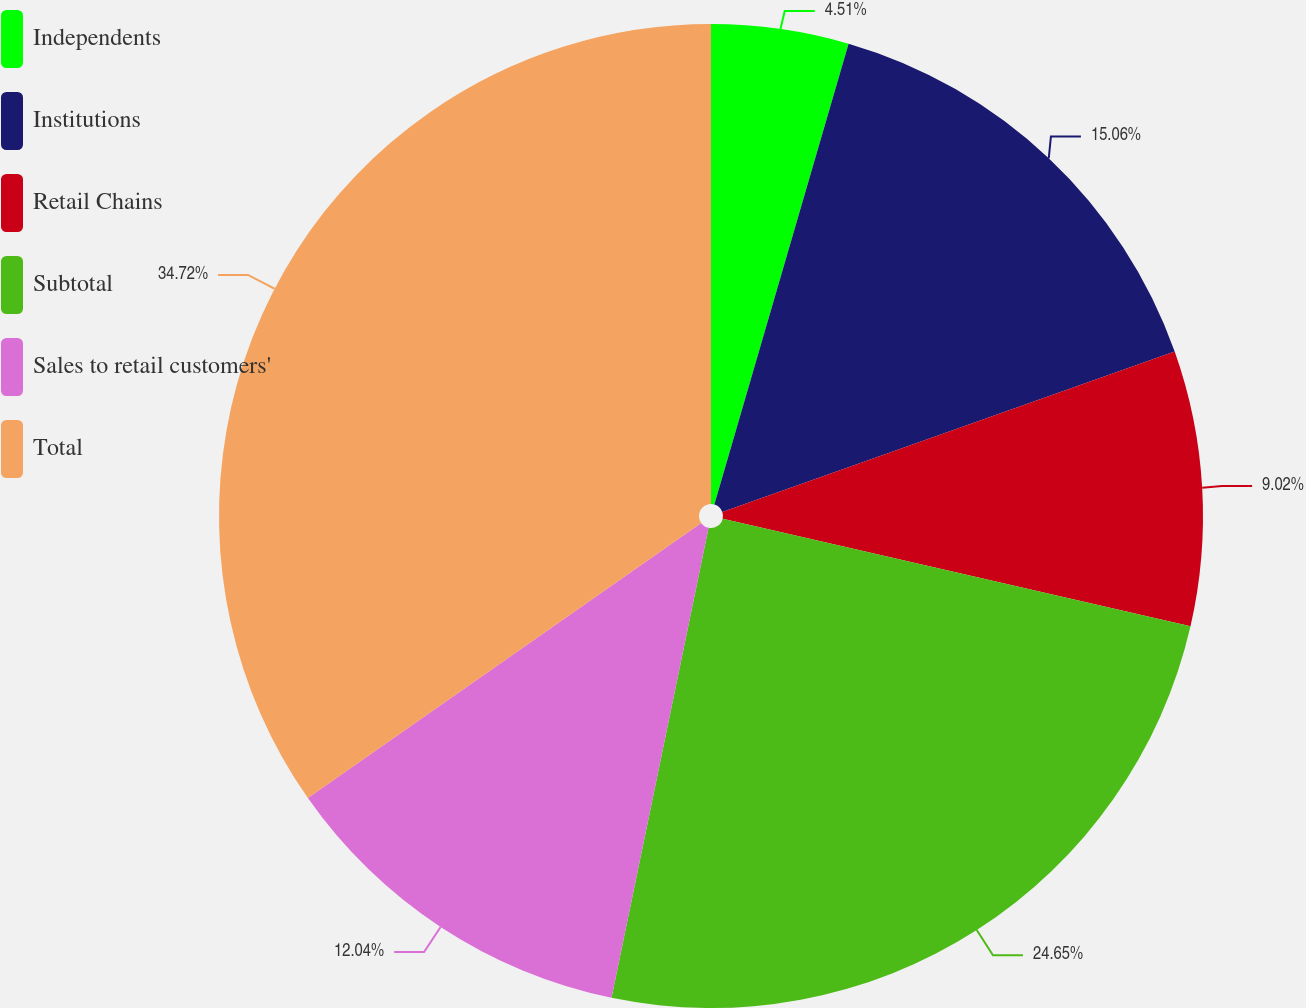<chart> <loc_0><loc_0><loc_500><loc_500><pie_chart><fcel>Independents<fcel>Institutions<fcel>Retail Chains<fcel>Subtotal<fcel>Sales to retail customers'<fcel>Total<nl><fcel>4.51%<fcel>15.06%<fcel>9.02%<fcel>24.64%<fcel>12.04%<fcel>34.71%<nl></chart> 